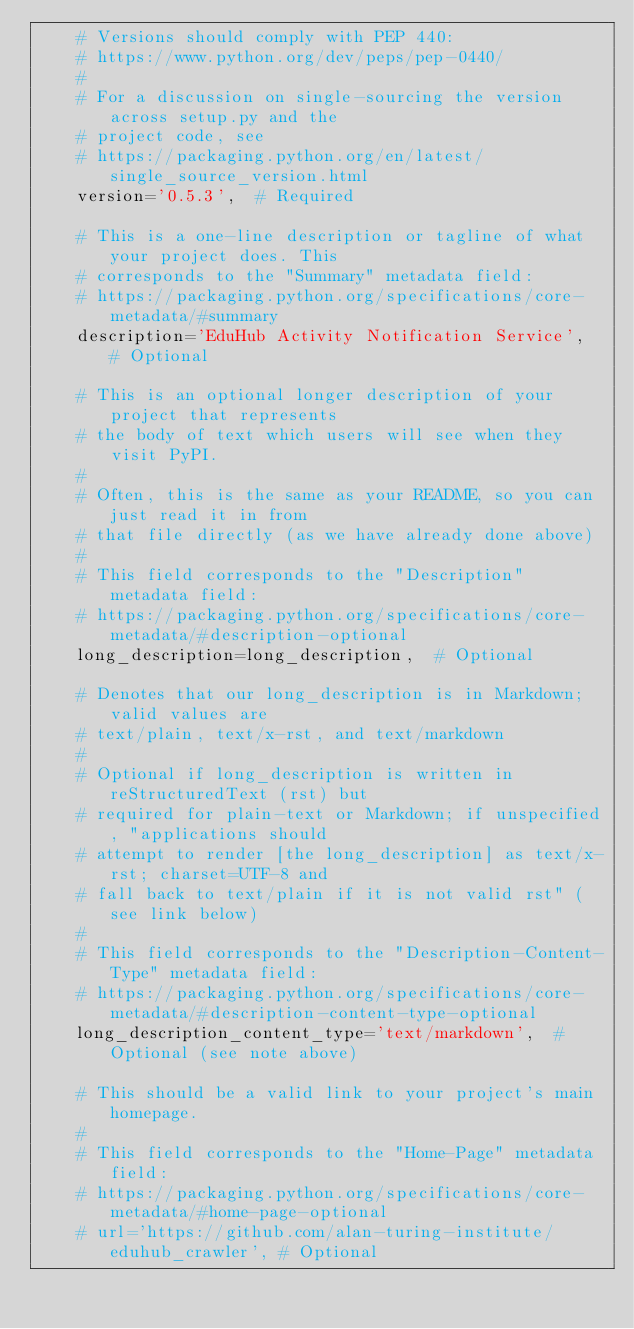Convert code to text. <code><loc_0><loc_0><loc_500><loc_500><_Python_>    # Versions should comply with PEP 440:
    # https://www.python.org/dev/peps/pep-0440/
    #
    # For a discussion on single-sourcing the version across setup.py and the
    # project code, see
    # https://packaging.python.org/en/latest/single_source_version.html
    version='0.5.3',  # Required

    # This is a one-line description or tagline of what your project does. This
    # corresponds to the "Summary" metadata field:
    # https://packaging.python.org/specifications/core-metadata/#summary
    description='EduHub Activity Notification Service',  # Optional

    # This is an optional longer description of your project that represents
    # the body of text which users will see when they visit PyPI.
    #
    # Often, this is the same as your README, so you can just read it in from
    # that file directly (as we have already done above)
    #
    # This field corresponds to the "Description" metadata field:
    # https://packaging.python.org/specifications/core-metadata/#description-optional
    long_description=long_description,  # Optional

    # Denotes that our long_description is in Markdown; valid values are
    # text/plain, text/x-rst, and text/markdown
    #
    # Optional if long_description is written in reStructuredText (rst) but
    # required for plain-text or Markdown; if unspecified, "applications should
    # attempt to render [the long_description] as text/x-rst; charset=UTF-8 and
    # fall back to text/plain if it is not valid rst" (see link below)
    #
    # This field corresponds to the "Description-Content-Type" metadata field:
    # https://packaging.python.org/specifications/core-metadata/#description-content-type-optional
    long_description_content_type='text/markdown',  # Optional (see note above)

    # This should be a valid link to your project's main homepage.
    #
    # This field corresponds to the "Home-Page" metadata field:
    # https://packaging.python.org/specifications/core-metadata/#home-page-optional
    # url='https://github.com/alan-turing-institute/eduhub_crawler', # Optional
</code> 